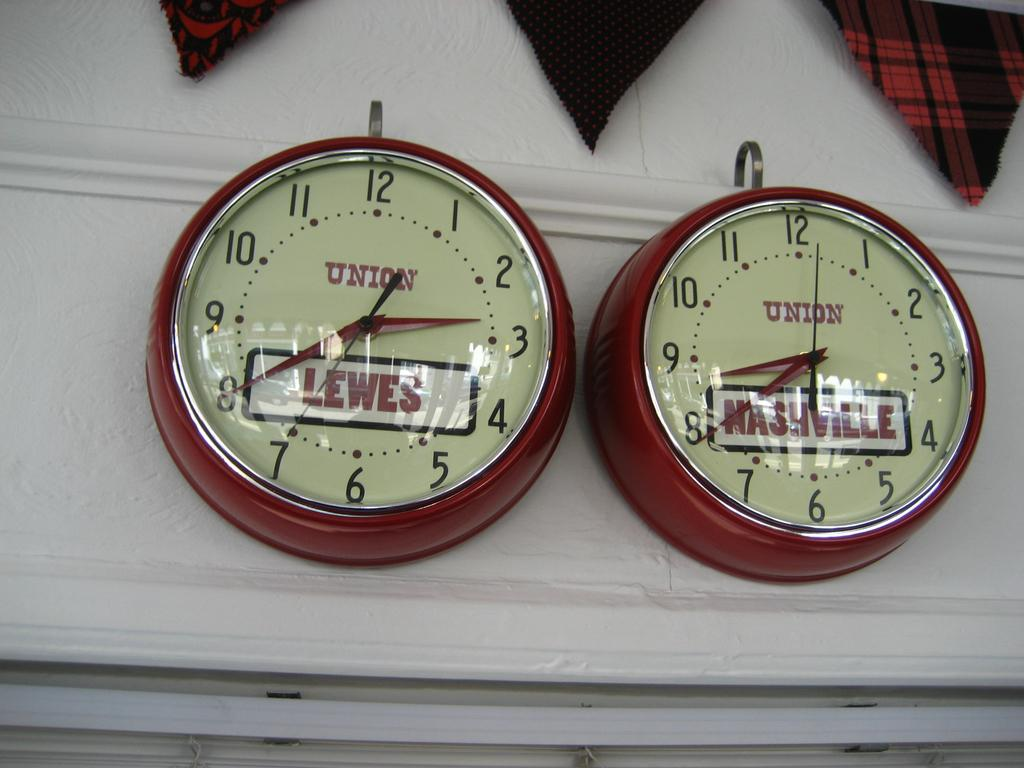<image>
Present a compact description of the photo's key features. a set of two clocks that are from the brand union 